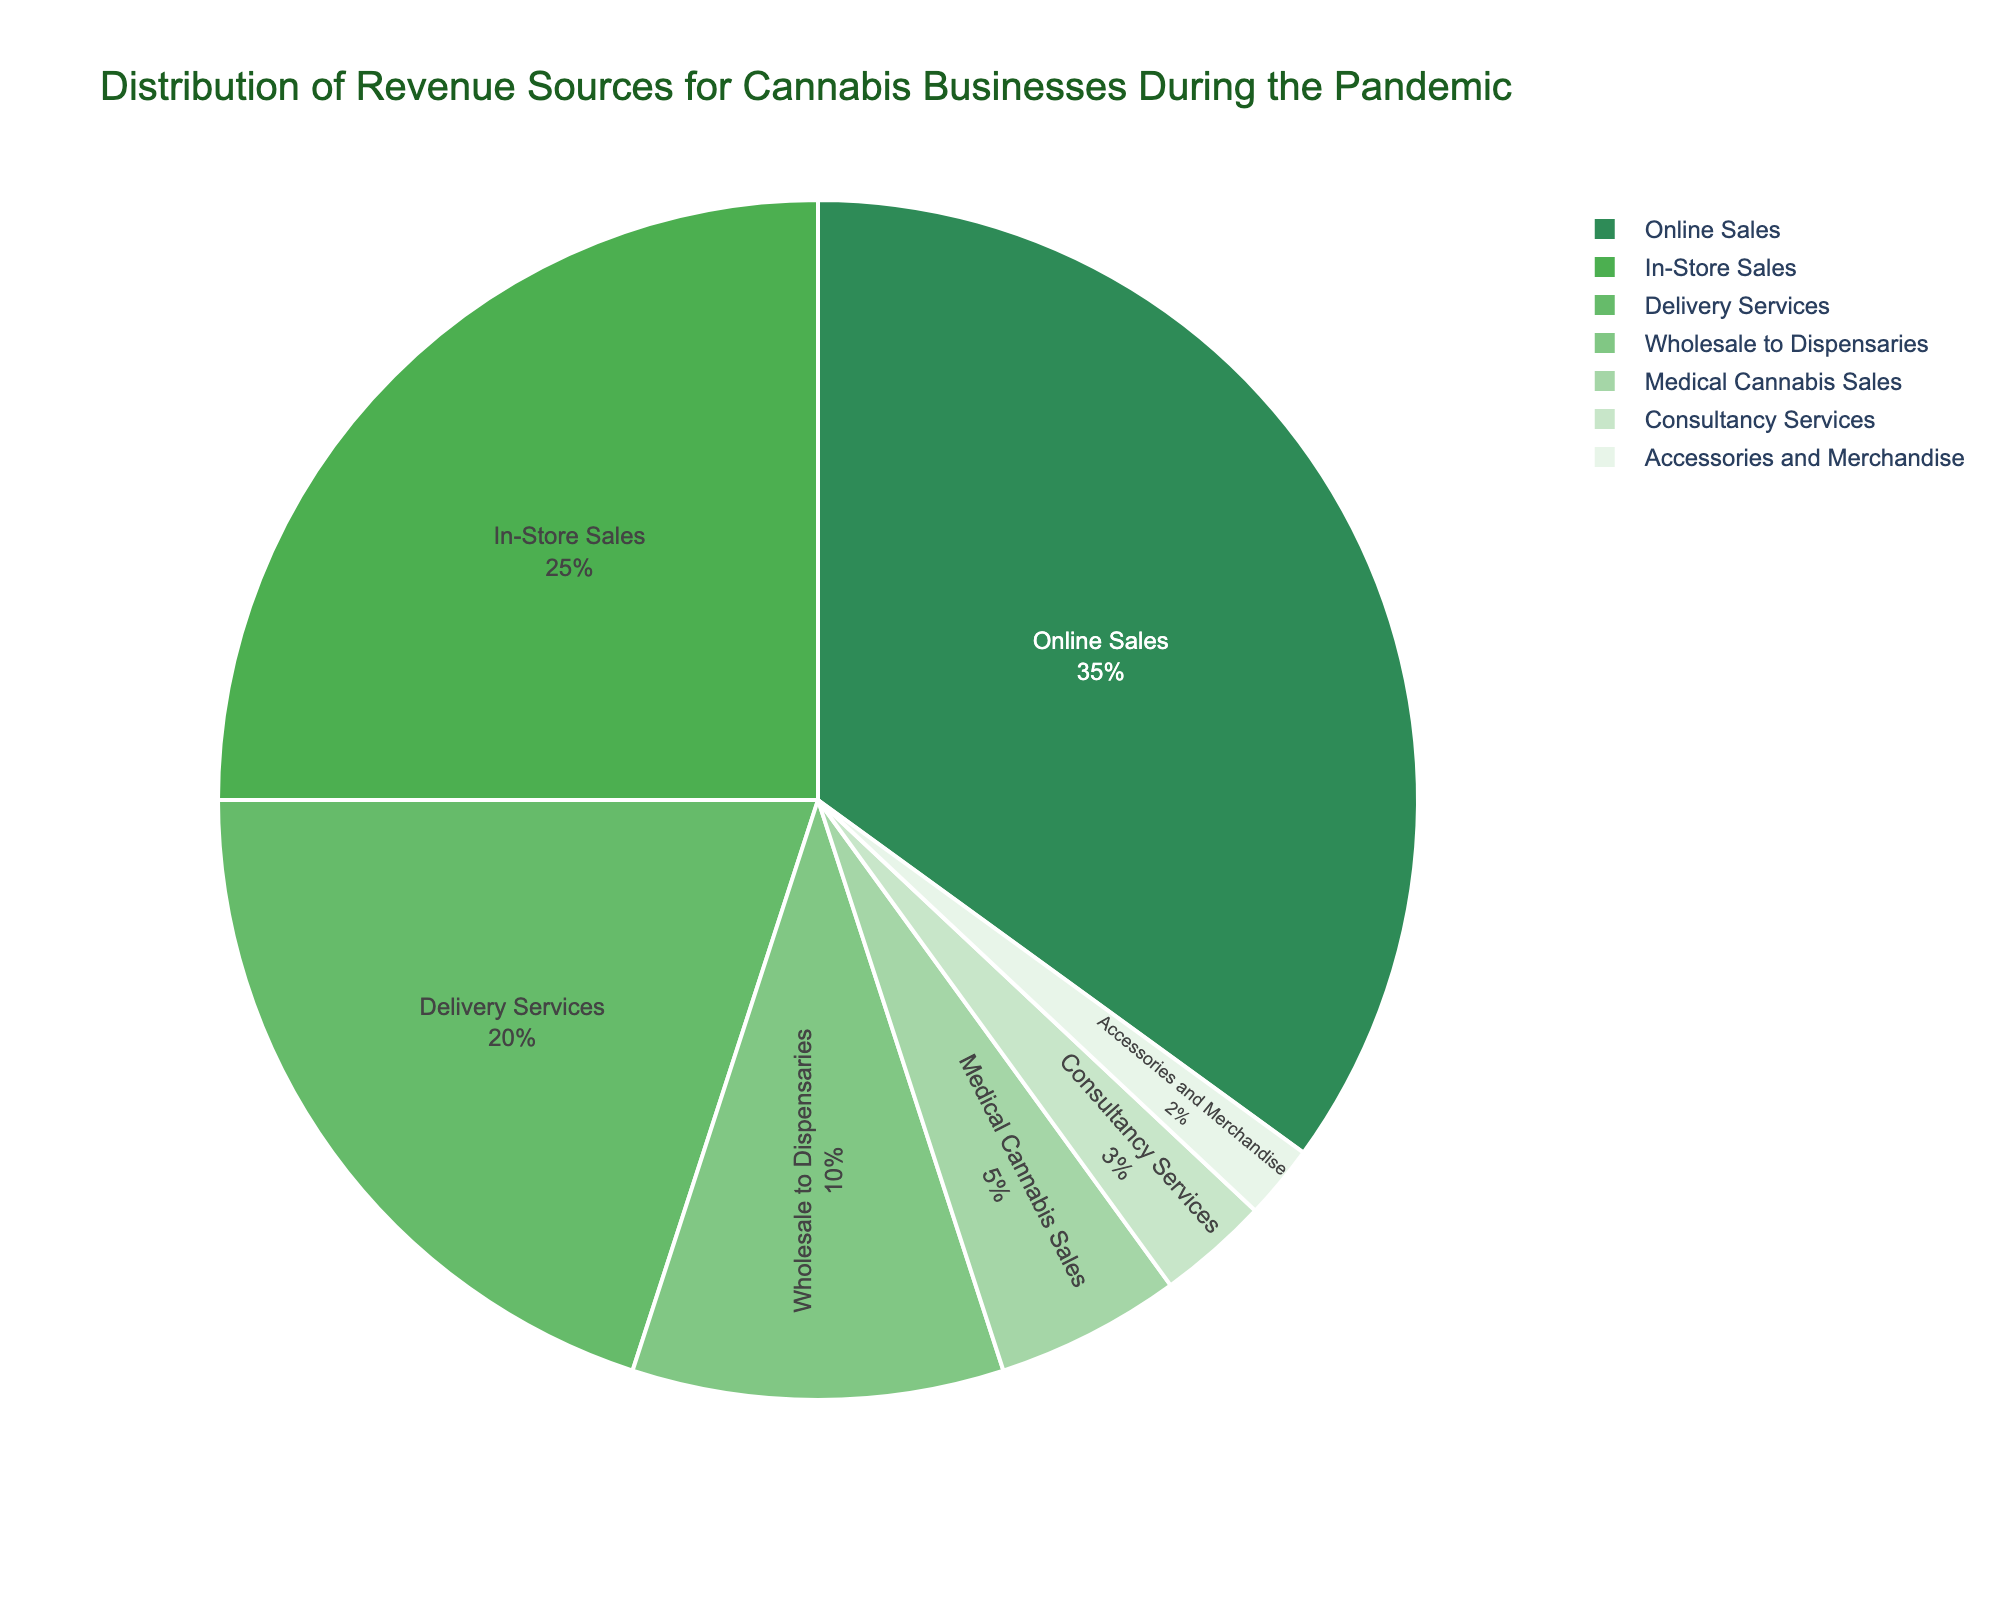what is the smallest source of revenue? By looking at the slices of the pie chart, the smallest portion corresponds to Accessories and Merchandise with a percentage of 2%.
Answer: Accessories and Merchandise What percentage of revenue comes from Online Sales and Delivery Services combined? Online Sales contributes 35% and Delivery Services contributes 20%. Adding these together gives 35% + 20% = 55%.
Answer: 55% Which category has a higher revenue percentage, In-Store Sales or Wholesale to Dispensaries? From the pie chart, In-Store Sales has a percentage of 25% while Wholesale to Dispensaries has a percentage of 10%. 25% is greater than 10%.
Answer: In-Store Sales By how much does Medical Cannabis Sales revenue fall short compared to Online Sales revenue? Online Sales has a percentage of 35% while Medical Cannabis Sales has 5%. Subtracting these gives 35% - 5% = 30%.
Answer: 30% How does the percentage of Delivery Services compare to that of Consultancy Services? Delivery Services revenue is 20% and Consultancy Services is 3%. 20% is greater than 3% by 17%.
Answer: 17% What are the total contributions of revenue sources that are under 10%? The categories under 10% are Wholesale to Dispensaries (10%), Medical Cannabis Sales (5%), Consultancy Services (3%), and Accessories and Merchandise (2%). Adding these gives 10% + 5% + 3% + 2% = 20%.
Answer: 20% How much more significant is the revenue from In-Store Sales compared to Medical Cannabis Sales? In-Store Sales contribute 25% to the revenue, while Medical Cannabis Sales contribute 5%. The difference is 25% - 5% = 20%.
Answer: 20% Is the contribution from Online Sales more than the combined total of Medical Cannabis Sales and Consultancy Services? Medical Cannabis Sales contribute 5% and Consultancy Services contribute 3%. Their combined total is 5% + 3% = 8%. Online Sales alone contribute 35%, which is greater than 8%.
Answer: Yes Which revenue source holds the third-largest share? The third-largest portion of the pie chart corresponds to Delivery Services with a revenue percentage of 20%.
Answer: Delivery Services What is the cumulative percentage of In-Store Sales and Delivery Services? In-Store Sales contribute 25% and Delivery Services contribute 20%. Adding these up gives 25% + 20% = 45%.
Answer: 45% 